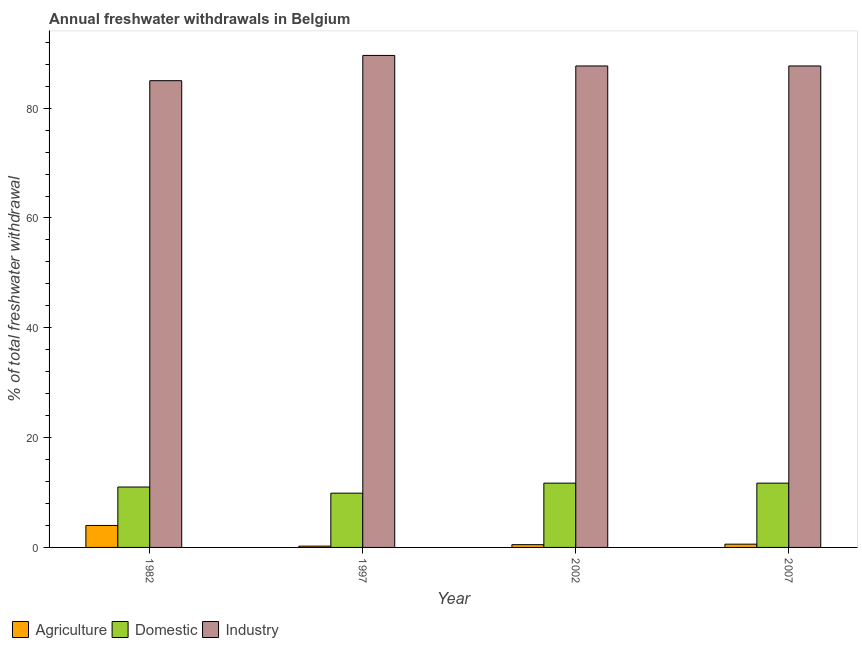How many different coloured bars are there?
Your answer should be compact. 3. In how many cases, is the number of bars for a given year not equal to the number of legend labels?
Offer a terse response. 0. What is the percentage of freshwater withdrawal for agriculture in 1997?
Provide a succinct answer. 0.24. Across all years, what is the maximum percentage of freshwater withdrawal for domestic purposes?
Ensure brevity in your answer.  11.71. Across all years, what is the minimum percentage of freshwater withdrawal for domestic purposes?
Offer a very short reply. 9.88. In which year was the percentage of freshwater withdrawal for agriculture minimum?
Give a very brief answer. 1997. What is the total percentage of freshwater withdrawal for domestic purposes in the graph?
Keep it short and to the point. 44.3. What is the difference between the percentage of freshwater withdrawal for agriculture in 1982 and that in 2007?
Your response must be concise. 3.4. What is the difference between the percentage of freshwater withdrawal for domestic purposes in 1997 and the percentage of freshwater withdrawal for agriculture in 2002?
Make the answer very short. -1.83. What is the average percentage of freshwater withdrawal for domestic purposes per year?
Offer a terse response. 11.08. In the year 2002, what is the difference between the percentage of freshwater withdrawal for industry and percentage of freshwater withdrawal for agriculture?
Give a very brief answer. 0. In how many years, is the percentage of freshwater withdrawal for agriculture greater than 52 %?
Give a very brief answer. 0. What is the ratio of the percentage of freshwater withdrawal for domestic purposes in 1982 to that in 1997?
Offer a terse response. 1.11. Is the percentage of freshwater withdrawal for agriculture in 1982 less than that in 2002?
Your response must be concise. No. What is the difference between the highest and the lowest percentage of freshwater withdrawal for industry?
Make the answer very short. 4.6. In how many years, is the percentage of freshwater withdrawal for industry greater than the average percentage of freshwater withdrawal for industry taken over all years?
Provide a succinct answer. 3. Is the sum of the percentage of freshwater withdrawal for agriculture in 1982 and 2007 greater than the maximum percentage of freshwater withdrawal for industry across all years?
Ensure brevity in your answer.  Yes. What does the 1st bar from the left in 1997 represents?
Provide a succinct answer. Agriculture. What does the 1st bar from the right in 2002 represents?
Make the answer very short. Industry. Is it the case that in every year, the sum of the percentage of freshwater withdrawal for agriculture and percentage of freshwater withdrawal for domestic purposes is greater than the percentage of freshwater withdrawal for industry?
Offer a very short reply. No. What is the difference between two consecutive major ticks on the Y-axis?
Your answer should be compact. 20. Does the graph contain any zero values?
Offer a very short reply. No. Does the graph contain grids?
Ensure brevity in your answer.  No. What is the title of the graph?
Offer a terse response. Annual freshwater withdrawals in Belgium. What is the label or title of the X-axis?
Your response must be concise. Year. What is the label or title of the Y-axis?
Offer a very short reply. % of total freshwater withdrawal. What is the % of total freshwater withdrawal in Agriculture in 1982?
Keep it short and to the point. 4. What is the % of total freshwater withdrawal of Industry in 1982?
Keep it short and to the point. 85.01. What is the % of total freshwater withdrawal in Agriculture in 1997?
Your answer should be compact. 0.24. What is the % of total freshwater withdrawal of Domestic in 1997?
Your response must be concise. 9.88. What is the % of total freshwater withdrawal of Industry in 1997?
Offer a very short reply. 89.61. What is the % of total freshwater withdrawal in Agriculture in 2002?
Ensure brevity in your answer.  0.5. What is the % of total freshwater withdrawal of Domestic in 2002?
Keep it short and to the point. 11.71. What is the % of total freshwater withdrawal in Industry in 2002?
Your answer should be very brief. 87.69. What is the % of total freshwater withdrawal of Agriculture in 2007?
Offer a terse response. 0.6. What is the % of total freshwater withdrawal in Domestic in 2007?
Make the answer very short. 11.71. What is the % of total freshwater withdrawal of Industry in 2007?
Keep it short and to the point. 87.69. Across all years, what is the maximum % of total freshwater withdrawal in Agriculture?
Your answer should be very brief. 4. Across all years, what is the maximum % of total freshwater withdrawal of Domestic?
Your response must be concise. 11.71. Across all years, what is the maximum % of total freshwater withdrawal of Industry?
Offer a terse response. 89.61. Across all years, what is the minimum % of total freshwater withdrawal in Agriculture?
Your response must be concise. 0.24. Across all years, what is the minimum % of total freshwater withdrawal of Domestic?
Make the answer very short. 9.88. Across all years, what is the minimum % of total freshwater withdrawal in Industry?
Offer a very short reply. 85.01. What is the total % of total freshwater withdrawal of Agriculture in the graph?
Provide a short and direct response. 5.34. What is the total % of total freshwater withdrawal in Domestic in the graph?
Make the answer very short. 44.3. What is the total % of total freshwater withdrawal in Industry in the graph?
Offer a very short reply. 350. What is the difference between the % of total freshwater withdrawal of Agriculture in 1982 and that in 1997?
Give a very brief answer. 3.76. What is the difference between the % of total freshwater withdrawal in Domestic in 1982 and that in 1997?
Your answer should be very brief. 1.12. What is the difference between the % of total freshwater withdrawal in Agriculture in 1982 and that in 2002?
Your answer should be very brief. 3.5. What is the difference between the % of total freshwater withdrawal in Domestic in 1982 and that in 2002?
Your answer should be compact. -0.71. What is the difference between the % of total freshwater withdrawal of Industry in 1982 and that in 2002?
Provide a short and direct response. -2.68. What is the difference between the % of total freshwater withdrawal in Agriculture in 1982 and that in 2007?
Ensure brevity in your answer.  3.4. What is the difference between the % of total freshwater withdrawal in Domestic in 1982 and that in 2007?
Offer a very short reply. -0.71. What is the difference between the % of total freshwater withdrawal in Industry in 1982 and that in 2007?
Make the answer very short. -2.68. What is the difference between the % of total freshwater withdrawal of Agriculture in 1997 and that in 2002?
Your answer should be very brief. -0.27. What is the difference between the % of total freshwater withdrawal in Domestic in 1997 and that in 2002?
Provide a succinct answer. -1.83. What is the difference between the % of total freshwater withdrawal of Industry in 1997 and that in 2002?
Give a very brief answer. 1.92. What is the difference between the % of total freshwater withdrawal in Agriculture in 1997 and that in 2007?
Make the answer very short. -0.36. What is the difference between the % of total freshwater withdrawal in Domestic in 1997 and that in 2007?
Offer a terse response. -1.83. What is the difference between the % of total freshwater withdrawal of Industry in 1997 and that in 2007?
Offer a terse response. 1.92. What is the difference between the % of total freshwater withdrawal in Agriculture in 2002 and that in 2007?
Offer a terse response. -0.09. What is the difference between the % of total freshwater withdrawal of Domestic in 2002 and that in 2007?
Offer a very short reply. 0. What is the difference between the % of total freshwater withdrawal in Agriculture in 1982 and the % of total freshwater withdrawal in Domestic in 1997?
Make the answer very short. -5.88. What is the difference between the % of total freshwater withdrawal in Agriculture in 1982 and the % of total freshwater withdrawal in Industry in 1997?
Make the answer very short. -85.61. What is the difference between the % of total freshwater withdrawal in Domestic in 1982 and the % of total freshwater withdrawal in Industry in 1997?
Ensure brevity in your answer.  -78.61. What is the difference between the % of total freshwater withdrawal in Agriculture in 1982 and the % of total freshwater withdrawal in Domestic in 2002?
Provide a succinct answer. -7.71. What is the difference between the % of total freshwater withdrawal in Agriculture in 1982 and the % of total freshwater withdrawal in Industry in 2002?
Provide a short and direct response. -83.69. What is the difference between the % of total freshwater withdrawal of Domestic in 1982 and the % of total freshwater withdrawal of Industry in 2002?
Offer a very short reply. -76.69. What is the difference between the % of total freshwater withdrawal in Agriculture in 1982 and the % of total freshwater withdrawal in Domestic in 2007?
Provide a succinct answer. -7.71. What is the difference between the % of total freshwater withdrawal in Agriculture in 1982 and the % of total freshwater withdrawal in Industry in 2007?
Ensure brevity in your answer.  -83.69. What is the difference between the % of total freshwater withdrawal in Domestic in 1982 and the % of total freshwater withdrawal in Industry in 2007?
Ensure brevity in your answer.  -76.69. What is the difference between the % of total freshwater withdrawal of Agriculture in 1997 and the % of total freshwater withdrawal of Domestic in 2002?
Give a very brief answer. -11.47. What is the difference between the % of total freshwater withdrawal in Agriculture in 1997 and the % of total freshwater withdrawal in Industry in 2002?
Ensure brevity in your answer.  -87.45. What is the difference between the % of total freshwater withdrawal of Domestic in 1997 and the % of total freshwater withdrawal of Industry in 2002?
Offer a very short reply. -77.81. What is the difference between the % of total freshwater withdrawal of Agriculture in 1997 and the % of total freshwater withdrawal of Domestic in 2007?
Ensure brevity in your answer.  -11.47. What is the difference between the % of total freshwater withdrawal of Agriculture in 1997 and the % of total freshwater withdrawal of Industry in 2007?
Your answer should be very brief. -87.45. What is the difference between the % of total freshwater withdrawal of Domestic in 1997 and the % of total freshwater withdrawal of Industry in 2007?
Ensure brevity in your answer.  -77.81. What is the difference between the % of total freshwater withdrawal of Agriculture in 2002 and the % of total freshwater withdrawal of Domestic in 2007?
Your response must be concise. -11.21. What is the difference between the % of total freshwater withdrawal in Agriculture in 2002 and the % of total freshwater withdrawal in Industry in 2007?
Offer a terse response. -87.19. What is the difference between the % of total freshwater withdrawal in Domestic in 2002 and the % of total freshwater withdrawal in Industry in 2007?
Keep it short and to the point. -75.98. What is the average % of total freshwater withdrawal in Agriculture per year?
Offer a very short reply. 1.33. What is the average % of total freshwater withdrawal of Domestic per year?
Ensure brevity in your answer.  11.08. What is the average % of total freshwater withdrawal of Industry per year?
Your answer should be very brief. 87.5. In the year 1982, what is the difference between the % of total freshwater withdrawal of Agriculture and % of total freshwater withdrawal of Domestic?
Your answer should be compact. -7. In the year 1982, what is the difference between the % of total freshwater withdrawal of Agriculture and % of total freshwater withdrawal of Industry?
Give a very brief answer. -81.01. In the year 1982, what is the difference between the % of total freshwater withdrawal of Domestic and % of total freshwater withdrawal of Industry?
Your answer should be very brief. -74.01. In the year 1997, what is the difference between the % of total freshwater withdrawal in Agriculture and % of total freshwater withdrawal in Domestic?
Offer a very short reply. -9.65. In the year 1997, what is the difference between the % of total freshwater withdrawal of Agriculture and % of total freshwater withdrawal of Industry?
Offer a terse response. -89.37. In the year 1997, what is the difference between the % of total freshwater withdrawal in Domestic and % of total freshwater withdrawal in Industry?
Your answer should be very brief. -79.73. In the year 2002, what is the difference between the % of total freshwater withdrawal of Agriculture and % of total freshwater withdrawal of Domestic?
Your response must be concise. -11.21. In the year 2002, what is the difference between the % of total freshwater withdrawal in Agriculture and % of total freshwater withdrawal in Industry?
Offer a very short reply. -87.19. In the year 2002, what is the difference between the % of total freshwater withdrawal in Domestic and % of total freshwater withdrawal in Industry?
Make the answer very short. -75.98. In the year 2007, what is the difference between the % of total freshwater withdrawal of Agriculture and % of total freshwater withdrawal of Domestic?
Your answer should be very brief. -11.11. In the year 2007, what is the difference between the % of total freshwater withdrawal of Agriculture and % of total freshwater withdrawal of Industry?
Your answer should be very brief. -87.09. In the year 2007, what is the difference between the % of total freshwater withdrawal of Domestic and % of total freshwater withdrawal of Industry?
Your response must be concise. -75.98. What is the ratio of the % of total freshwater withdrawal in Agriculture in 1982 to that in 1997?
Provide a succinct answer. 16.93. What is the ratio of the % of total freshwater withdrawal of Domestic in 1982 to that in 1997?
Provide a short and direct response. 1.11. What is the ratio of the % of total freshwater withdrawal in Industry in 1982 to that in 1997?
Your response must be concise. 0.95. What is the ratio of the % of total freshwater withdrawal in Agriculture in 1982 to that in 2002?
Your answer should be compact. 7.94. What is the ratio of the % of total freshwater withdrawal of Domestic in 1982 to that in 2002?
Your answer should be very brief. 0.94. What is the ratio of the % of total freshwater withdrawal of Industry in 1982 to that in 2002?
Offer a very short reply. 0.97. What is the ratio of the % of total freshwater withdrawal in Agriculture in 1982 to that in 2007?
Your response must be concise. 6.72. What is the ratio of the % of total freshwater withdrawal in Domestic in 1982 to that in 2007?
Offer a terse response. 0.94. What is the ratio of the % of total freshwater withdrawal in Industry in 1982 to that in 2007?
Keep it short and to the point. 0.97. What is the ratio of the % of total freshwater withdrawal in Agriculture in 1997 to that in 2002?
Offer a terse response. 0.47. What is the ratio of the % of total freshwater withdrawal of Domestic in 1997 to that in 2002?
Your response must be concise. 0.84. What is the ratio of the % of total freshwater withdrawal of Industry in 1997 to that in 2002?
Your response must be concise. 1.02. What is the ratio of the % of total freshwater withdrawal in Agriculture in 1997 to that in 2007?
Ensure brevity in your answer.  0.4. What is the ratio of the % of total freshwater withdrawal of Domestic in 1997 to that in 2007?
Your answer should be compact. 0.84. What is the ratio of the % of total freshwater withdrawal in Industry in 1997 to that in 2007?
Give a very brief answer. 1.02. What is the ratio of the % of total freshwater withdrawal of Agriculture in 2002 to that in 2007?
Offer a terse response. 0.85. What is the ratio of the % of total freshwater withdrawal of Industry in 2002 to that in 2007?
Ensure brevity in your answer.  1. What is the difference between the highest and the second highest % of total freshwater withdrawal in Agriculture?
Offer a terse response. 3.4. What is the difference between the highest and the second highest % of total freshwater withdrawal in Domestic?
Your answer should be compact. 0. What is the difference between the highest and the second highest % of total freshwater withdrawal of Industry?
Your answer should be compact. 1.92. What is the difference between the highest and the lowest % of total freshwater withdrawal in Agriculture?
Ensure brevity in your answer.  3.76. What is the difference between the highest and the lowest % of total freshwater withdrawal in Domestic?
Your answer should be very brief. 1.83. 